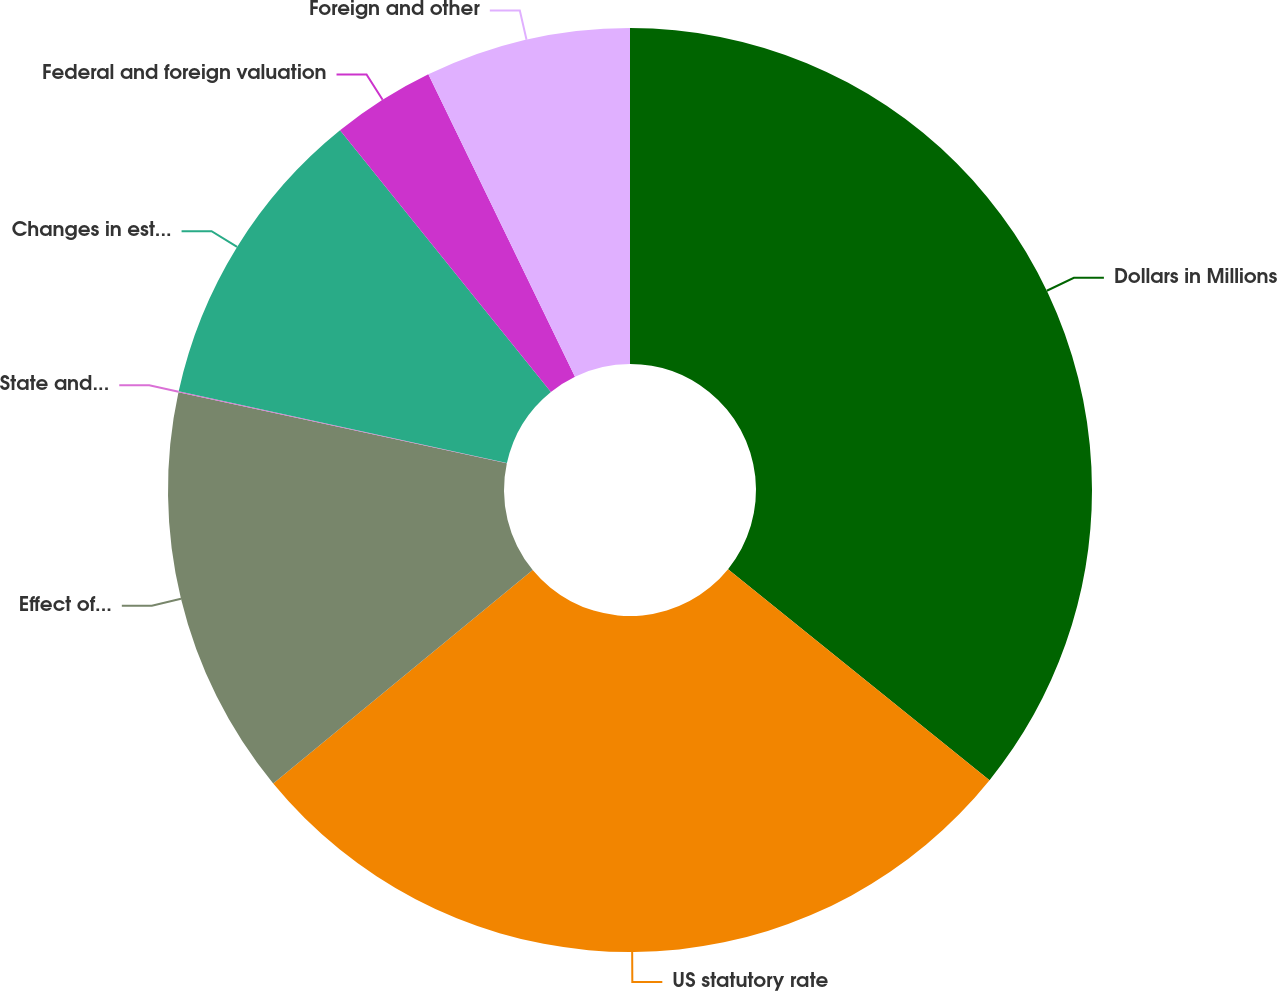Convert chart to OTSL. <chart><loc_0><loc_0><loc_500><loc_500><pie_chart><fcel>Dollars in Millions<fcel>US statutory rate<fcel>Effect of operations in<fcel>State and local taxes (net of<fcel>Changes in estimate for<fcel>Federal and foreign valuation<fcel>Foreign and other<nl><fcel>35.81%<fcel>28.24%<fcel>14.35%<fcel>0.04%<fcel>10.77%<fcel>3.61%<fcel>7.19%<nl></chart> 